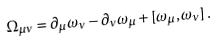Convert formula to latex. <formula><loc_0><loc_0><loc_500><loc_500>\Omega _ { \mu \nu } = \partial _ { \mu } \omega _ { \nu } - \partial _ { \nu } \omega _ { \mu } + [ \omega _ { \mu } , \omega _ { \nu } ] \, .</formula> 